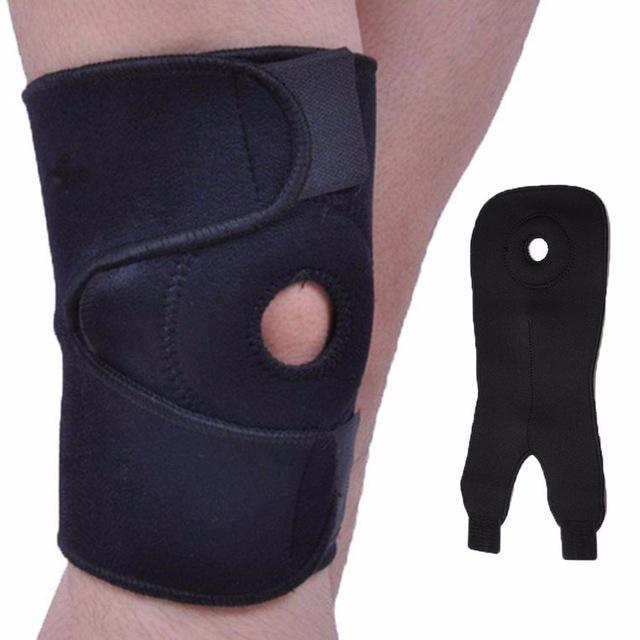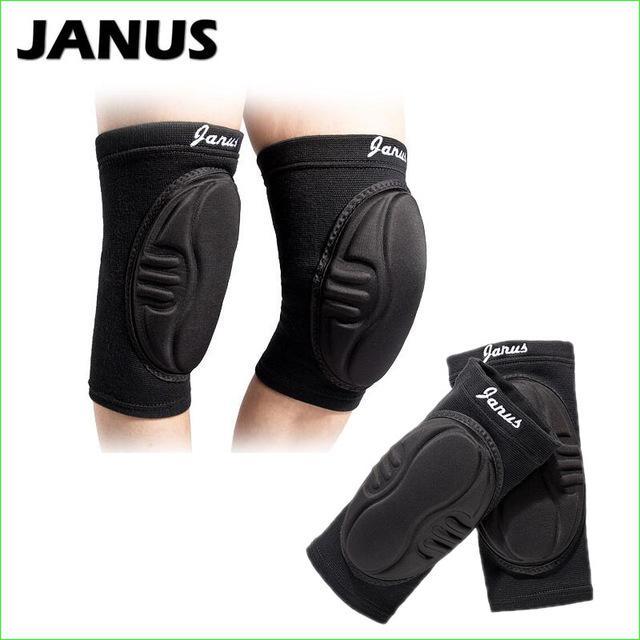The first image is the image on the left, the second image is the image on the right. For the images displayed, is the sentence "All knee pads are black, and each image includes a pair of legs with at least one leg wearing a knee pad." factually correct? Answer yes or no. Yes. The first image is the image on the left, the second image is the image on the right. For the images displayed, is the sentence "In at least one image there are four kneepads." factually correct? Answer yes or no. Yes. 